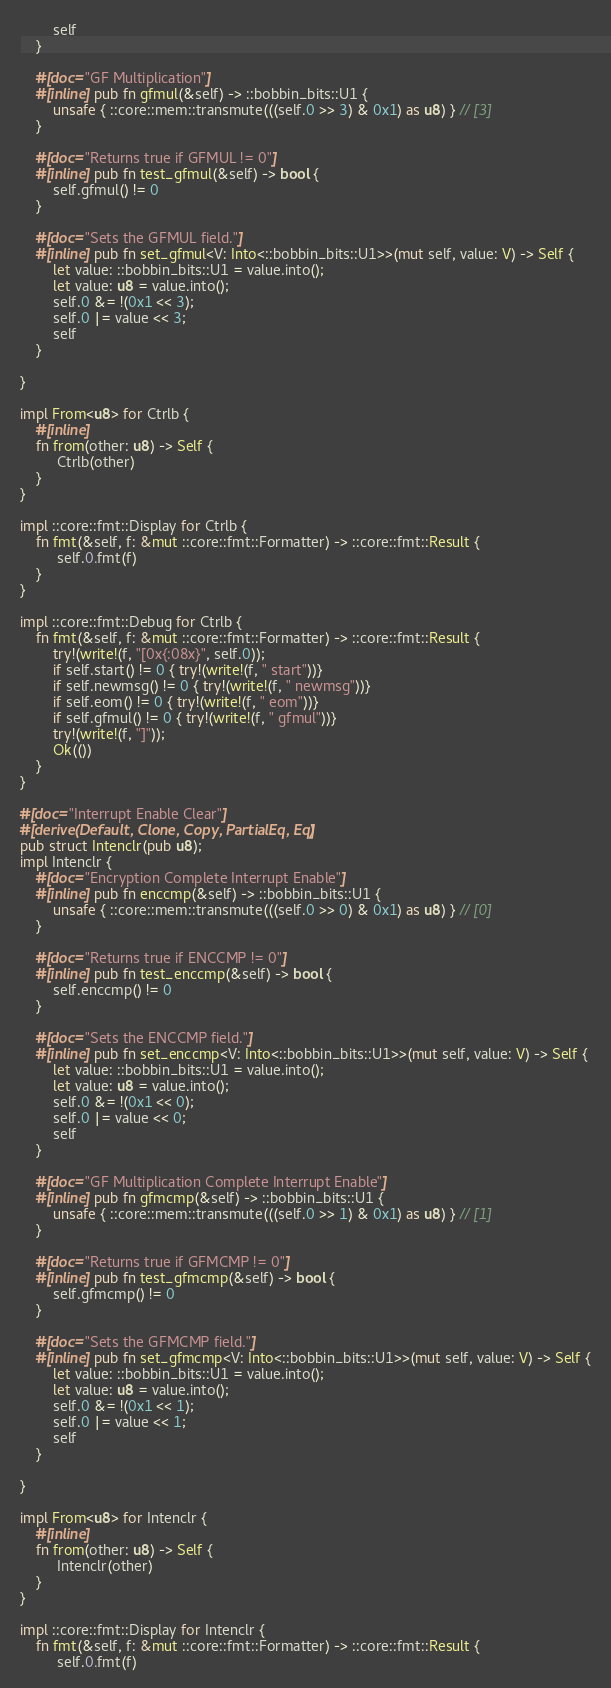Convert code to text. <code><loc_0><loc_0><loc_500><loc_500><_Rust_>        self
    }

    #[doc="GF Multiplication"]
    #[inline] pub fn gfmul(&self) -> ::bobbin_bits::U1 {
        unsafe { ::core::mem::transmute(((self.0 >> 3) & 0x1) as u8) } // [3]
    }

    #[doc="Returns true if GFMUL != 0"]
    #[inline] pub fn test_gfmul(&self) -> bool {
        self.gfmul() != 0
    }

    #[doc="Sets the GFMUL field."]
    #[inline] pub fn set_gfmul<V: Into<::bobbin_bits::U1>>(mut self, value: V) -> Self {
        let value: ::bobbin_bits::U1 = value.into();
        let value: u8 = value.into();
        self.0 &= !(0x1 << 3);
        self.0 |= value << 3;
        self
    }

}

impl From<u8> for Ctrlb {
    #[inline]
    fn from(other: u8) -> Self {
         Ctrlb(other)
    }
}

impl ::core::fmt::Display for Ctrlb {
    fn fmt(&self, f: &mut ::core::fmt::Formatter) -> ::core::fmt::Result {
         self.0.fmt(f)
    }
}

impl ::core::fmt::Debug for Ctrlb {
    fn fmt(&self, f: &mut ::core::fmt::Formatter) -> ::core::fmt::Result {
        try!(write!(f, "[0x{:08x}", self.0));
        if self.start() != 0 { try!(write!(f, " start"))}
        if self.newmsg() != 0 { try!(write!(f, " newmsg"))}
        if self.eom() != 0 { try!(write!(f, " eom"))}
        if self.gfmul() != 0 { try!(write!(f, " gfmul"))}
        try!(write!(f, "]"));
        Ok(())
    }
}

#[doc="Interrupt Enable Clear"]
#[derive(Default, Clone, Copy, PartialEq, Eq)]
pub struct Intenclr(pub u8);
impl Intenclr {
    #[doc="Encryption Complete Interrupt Enable"]
    #[inline] pub fn enccmp(&self) -> ::bobbin_bits::U1 {
        unsafe { ::core::mem::transmute(((self.0 >> 0) & 0x1) as u8) } // [0]
    }

    #[doc="Returns true if ENCCMP != 0"]
    #[inline] pub fn test_enccmp(&self) -> bool {
        self.enccmp() != 0
    }

    #[doc="Sets the ENCCMP field."]
    #[inline] pub fn set_enccmp<V: Into<::bobbin_bits::U1>>(mut self, value: V) -> Self {
        let value: ::bobbin_bits::U1 = value.into();
        let value: u8 = value.into();
        self.0 &= !(0x1 << 0);
        self.0 |= value << 0;
        self
    }

    #[doc="GF Multiplication Complete Interrupt Enable"]
    #[inline] pub fn gfmcmp(&self) -> ::bobbin_bits::U1 {
        unsafe { ::core::mem::transmute(((self.0 >> 1) & 0x1) as u8) } // [1]
    }

    #[doc="Returns true if GFMCMP != 0"]
    #[inline] pub fn test_gfmcmp(&self) -> bool {
        self.gfmcmp() != 0
    }

    #[doc="Sets the GFMCMP field."]
    #[inline] pub fn set_gfmcmp<V: Into<::bobbin_bits::U1>>(mut self, value: V) -> Self {
        let value: ::bobbin_bits::U1 = value.into();
        let value: u8 = value.into();
        self.0 &= !(0x1 << 1);
        self.0 |= value << 1;
        self
    }

}

impl From<u8> for Intenclr {
    #[inline]
    fn from(other: u8) -> Self {
         Intenclr(other)
    }
}

impl ::core::fmt::Display for Intenclr {
    fn fmt(&self, f: &mut ::core::fmt::Formatter) -> ::core::fmt::Result {
         self.0.fmt(f)</code> 